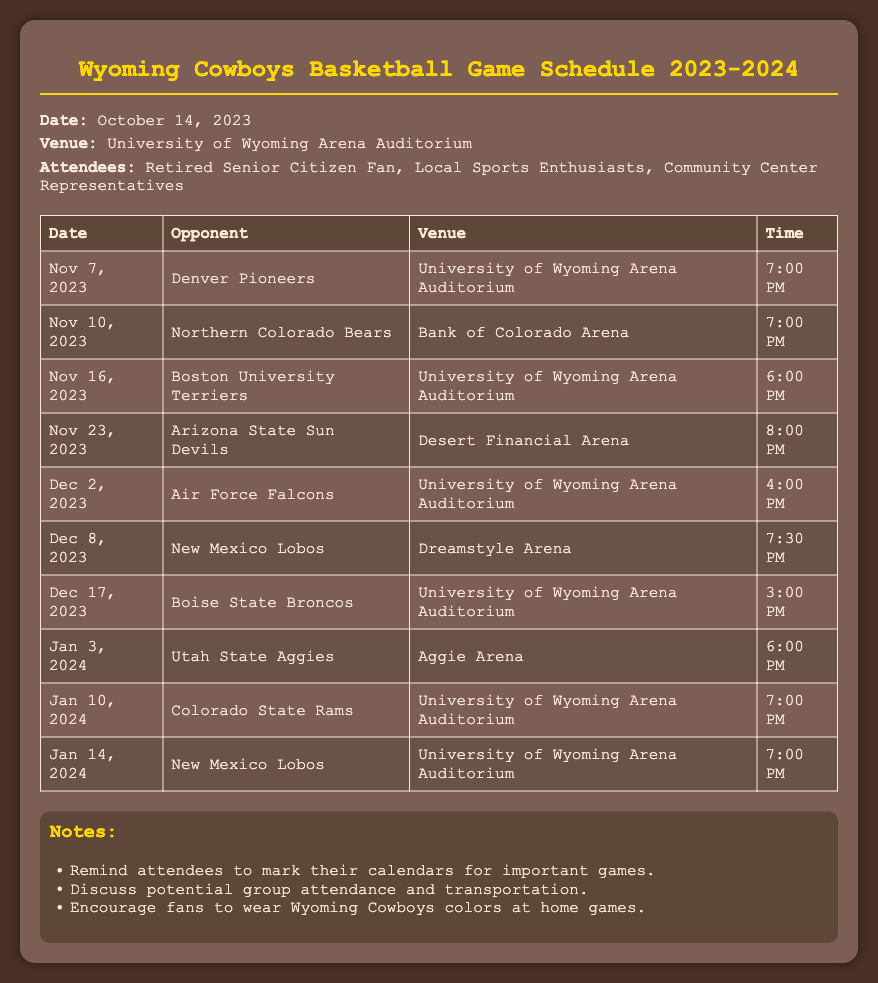What is the date of the first game? The first game is scheduled for November 7, 2023.
Answer: November 7, 2023 How many games are scheduled in December? There are three games scheduled in December, specifically on December 2, December 8, and December 17.
Answer: 3 What time is the game against the Northern Colorado Bears? The game against the Northern Colorado Bears is scheduled for 7:00 PM.
Answer: 7:00 PM Where is the game against the Arizona State Sun Devils taking place? The game against the Arizona State Sun Devils will be held at Desert Financial Arena.
Answer: Desert Financial Arena Which opponent do the Cowboys face on January 10, 2024? On January 10, 2024, the Cowboys will face the Colorado State Rams.
Answer: Colorado State Rams What is the venue for most of the home games? The majority of home games are played at the University of Wyoming Arena Auditorium.
Answer: University of Wyoming Arena Auditorium How many games are held at Aggie Arena? There is one game scheduled at Aggie Arena, which is against Utah State Aggies.
Answer: 1 What time is the game against the New Mexico Lobos on January 14, 2024? The game against the New Mexico Lobos on January 14, 2024, is at 7:00 PM.
Answer: 7:00 PM What is a notable suggestion for fans during home games? Fans are encouraged to wear Wyoming Cowboys colors at home games.
Answer: Wear Wyoming Cowboys colors 